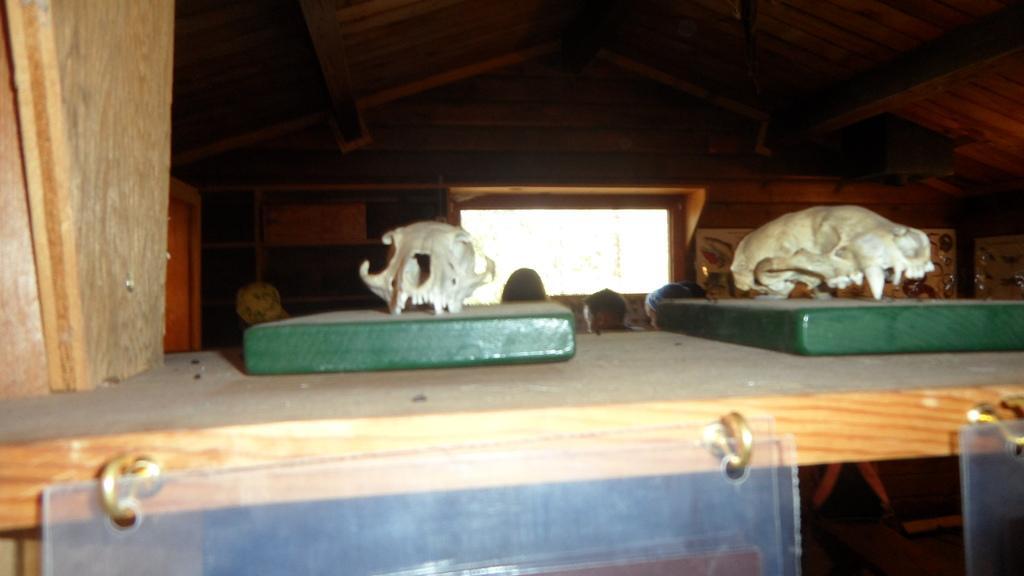Could you give a brief overview of what you see in this image? In this image, we can see green objects on the wooden shelf. On these green objects, we can see animal skulls. At the bottom of the image, there are boards attached to the hooks. In the background, we can see the people, wall, window, some objects and ceiling. 